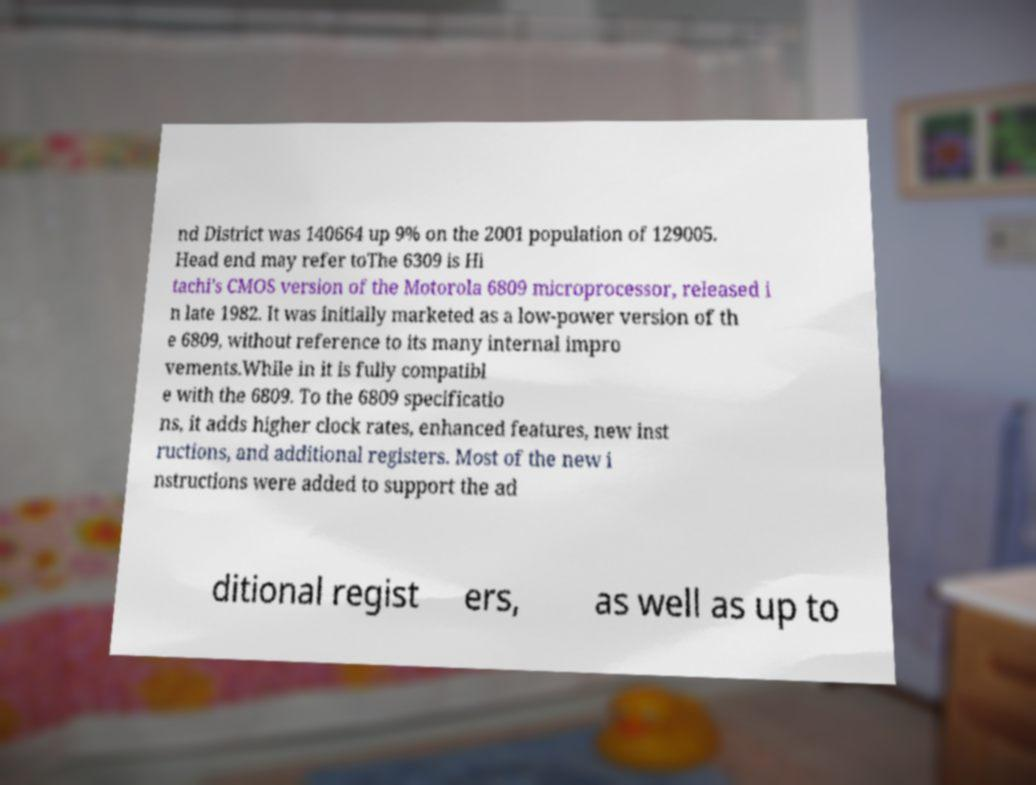Could you extract and type out the text from this image? nd District was 140664 up 9% on the 2001 population of 129005. Head end may refer toThe 6309 is Hi tachi's CMOS version of the Motorola 6809 microprocessor, released i n late 1982. It was initially marketed as a low-power version of th e 6809, without reference to its many internal impro vements.While in it is fully compatibl e with the 6809. To the 6809 specificatio ns, it adds higher clock rates, enhanced features, new inst ructions, and additional registers. Most of the new i nstructions were added to support the ad ditional regist ers, as well as up to 